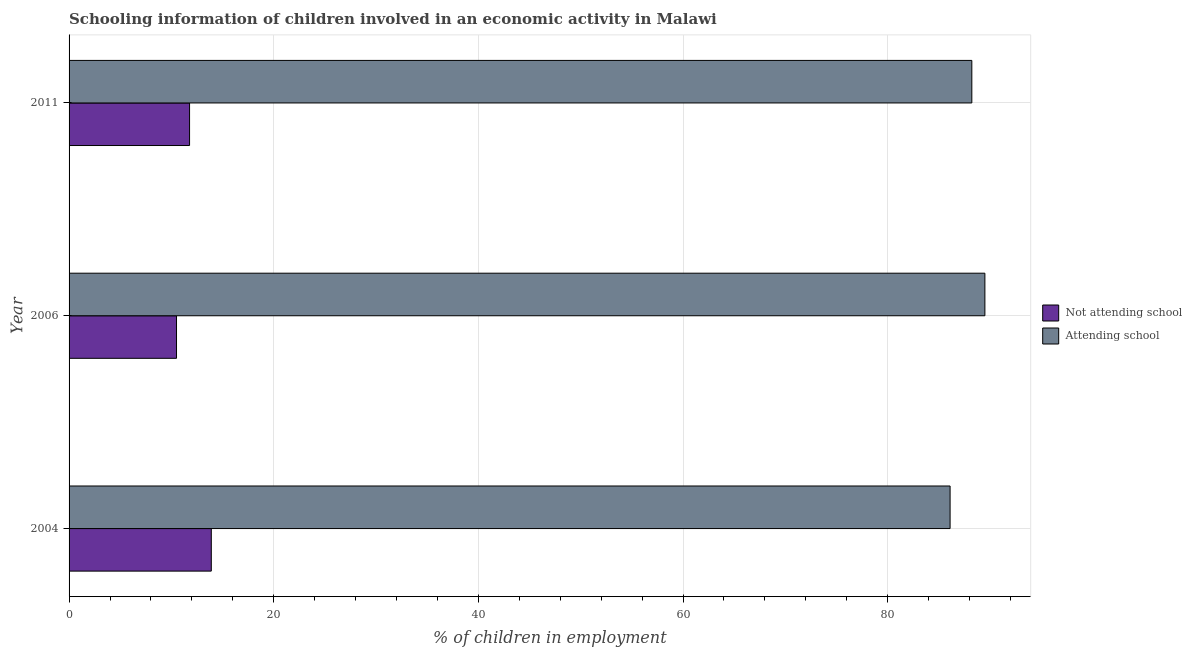Are the number of bars per tick equal to the number of legend labels?
Provide a short and direct response. Yes. How many bars are there on the 2nd tick from the bottom?
Keep it short and to the point. 2. What is the label of the 2nd group of bars from the top?
Offer a very short reply. 2006. In how many cases, is the number of bars for a given year not equal to the number of legend labels?
Keep it short and to the point. 0. What is the percentage of employed children who are attending school in 2006?
Your response must be concise. 89.5. Across all years, what is the minimum percentage of employed children who are not attending school?
Your answer should be very brief. 10.5. In which year was the percentage of employed children who are attending school maximum?
Your response must be concise. 2006. In which year was the percentage of employed children who are attending school minimum?
Your answer should be compact. 2004. What is the total percentage of employed children who are not attending school in the graph?
Your answer should be very brief. 36.18. What is the difference between the percentage of employed children who are not attending school in 2004 and that in 2011?
Make the answer very short. 2.12. What is the difference between the percentage of employed children who are not attending school in 2006 and the percentage of employed children who are attending school in 2004?
Keep it short and to the point. -75.6. What is the average percentage of employed children who are not attending school per year?
Provide a succinct answer. 12.06. In the year 2004, what is the difference between the percentage of employed children who are not attending school and percentage of employed children who are attending school?
Your answer should be compact. -72.2. In how many years, is the percentage of employed children who are not attending school greater than 60 %?
Offer a very short reply. 0. What is the ratio of the percentage of employed children who are attending school in 2006 to that in 2011?
Keep it short and to the point. 1.01. Is the difference between the percentage of employed children who are not attending school in 2004 and 2006 greater than the difference between the percentage of employed children who are attending school in 2004 and 2006?
Your answer should be compact. Yes. What is the difference between the highest and the second highest percentage of employed children who are not attending school?
Give a very brief answer. 2.12. What does the 2nd bar from the top in 2011 represents?
Provide a succinct answer. Not attending school. What does the 1st bar from the bottom in 2004 represents?
Provide a succinct answer. Not attending school. How many bars are there?
Keep it short and to the point. 6. Are all the bars in the graph horizontal?
Your response must be concise. Yes. Does the graph contain any zero values?
Provide a succinct answer. No. Where does the legend appear in the graph?
Keep it short and to the point. Center right. How many legend labels are there?
Offer a terse response. 2. What is the title of the graph?
Provide a succinct answer. Schooling information of children involved in an economic activity in Malawi. Does "Diarrhea" appear as one of the legend labels in the graph?
Your answer should be very brief. No. What is the label or title of the X-axis?
Offer a very short reply. % of children in employment. What is the label or title of the Y-axis?
Your answer should be very brief. Year. What is the % of children in employment in Attending school in 2004?
Keep it short and to the point. 86.1. What is the % of children in employment of Not attending school in 2006?
Provide a succinct answer. 10.5. What is the % of children in employment in Attending school in 2006?
Provide a succinct answer. 89.5. What is the % of children in employment of Not attending school in 2011?
Keep it short and to the point. 11.78. What is the % of children in employment of Attending school in 2011?
Keep it short and to the point. 88.22. Across all years, what is the maximum % of children in employment of Attending school?
Offer a very short reply. 89.5. Across all years, what is the minimum % of children in employment in Attending school?
Your answer should be very brief. 86.1. What is the total % of children in employment of Not attending school in the graph?
Your response must be concise. 36.18. What is the total % of children in employment in Attending school in the graph?
Your answer should be very brief. 263.82. What is the difference between the % of children in employment in Not attending school in 2004 and that in 2011?
Give a very brief answer. 2.12. What is the difference between the % of children in employment of Attending school in 2004 and that in 2011?
Ensure brevity in your answer.  -2.12. What is the difference between the % of children in employment of Not attending school in 2006 and that in 2011?
Make the answer very short. -1.28. What is the difference between the % of children in employment of Attending school in 2006 and that in 2011?
Provide a short and direct response. 1.28. What is the difference between the % of children in employment in Not attending school in 2004 and the % of children in employment in Attending school in 2006?
Provide a short and direct response. -75.6. What is the difference between the % of children in employment in Not attending school in 2004 and the % of children in employment in Attending school in 2011?
Offer a very short reply. -74.32. What is the difference between the % of children in employment in Not attending school in 2006 and the % of children in employment in Attending school in 2011?
Ensure brevity in your answer.  -77.72. What is the average % of children in employment of Not attending school per year?
Your response must be concise. 12.06. What is the average % of children in employment of Attending school per year?
Your answer should be very brief. 87.94. In the year 2004, what is the difference between the % of children in employment of Not attending school and % of children in employment of Attending school?
Keep it short and to the point. -72.2. In the year 2006, what is the difference between the % of children in employment in Not attending school and % of children in employment in Attending school?
Make the answer very short. -79. In the year 2011, what is the difference between the % of children in employment of Not attending school and % of children in employment of Attending school?
Provide a succinct answer. -76.45. What is the ratio of the % of children in employment in Not attending school in 2004 to that in 2006?
Offer a very short reply. 1.32. What is the ratio of the % of children in employment in Attending school in 2004 to that in 2006?
Keep it short and to the point. 0.96. What is the ratio of the % of children in employment in Not attending school in 2004 to that in 2011?
Your answer should be compact. 1.18. What is the ratio of the % of children in employment in Attending school in 2004 to that in 2011?
Your answer should be very brief. 0.98. What is the ratio of the % of children in employment of Not attending school in 2006 to that in 2011?
Provide a short and direct response. 0.89. What is the ratio of the % of children in employment in Attending school in 2006 to that in 2011?
Ensure brevity in your answer.  1.01. What is the difference between the highest and the second highest % of children in employment of Not attending school?
Offer a very short reply. 2.12. What is the difference between the highest and the second highest % of children in employment of Attending school?
Provide a short and direct response. 1.28. 